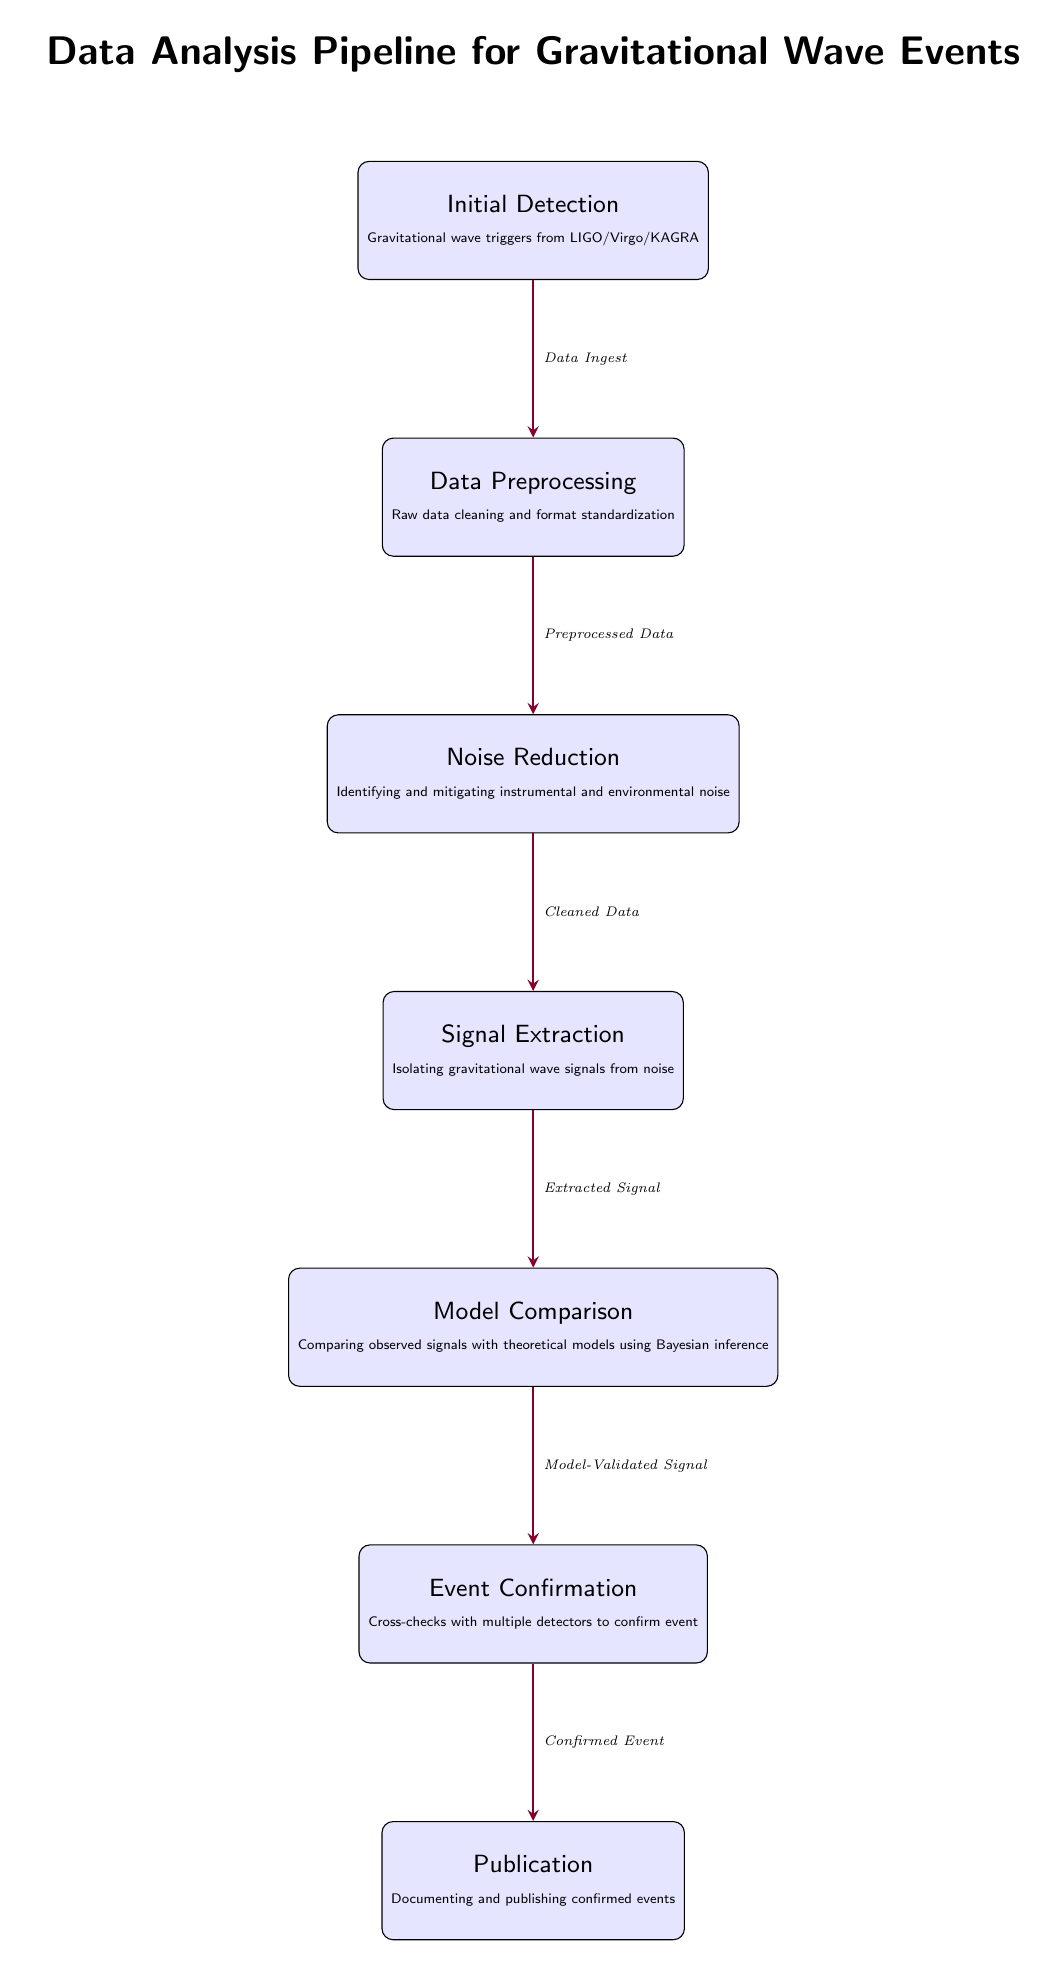What is the first stage in the data analysis pipeline? The first stage listed in the diagram is "Initial Detection," which refers to gravitational wave triggers from LIGO/Virgo/KAGRA.
Answer: Initial Detection How many nodes are displayed in the diagram? The diagram contains seven distinct nodes representing different stages of the data analysis process.
Answer: Seven What type of data is delivered from "Noise Reduction"? The output from the "Noise Reduction" stage is referred to as "Cleaned Data," indicating that data has been processed to remove noise.
Answer: Cleaned Data Which stage involves comparing observed signals with theoretical models? The stage where observed signals are compared to theoretical models is "Model Comparison," which utilizes Bayesian inference.
Answer: Model Comparison What is the final stage of the pipeline? The last stage in the process is "Publication," which includes documenting and publishing confirmed events.
Answer: Publication What is the relationship between "Signal Extraction" and "Model Comparison"? The "Signal Extraction" stage sends its output, labeled "Extracted Signal," directly to the "Model Comparison" stage for further analysis.
Answer: Extracted Signal What confirms the events in the data analysis pipeline? The stage tasked with confirming events is "Event Confirmation," which relies on cross-checks with multiple detectors to validate the findings.
Answer: Event Confirmation What type of inference is used during "Model Comparison"? The inference method utilized in "Model Comparison" is Bayesian inference, which helps in evaluating the theoretical models against the observed data.
Answer: Bayesian inference 